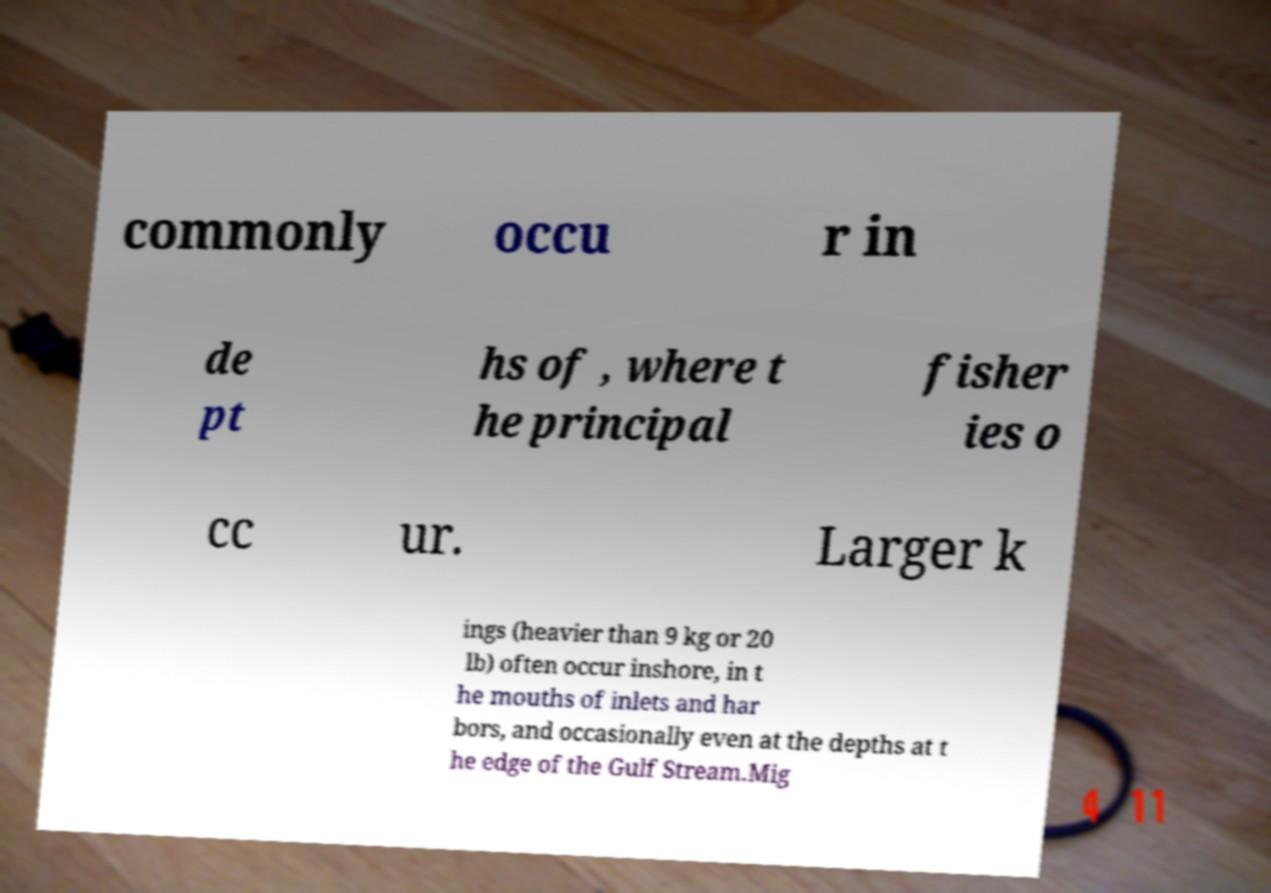Could you extract and type out the text from this image? commonly occu r in de pt hs of , where t he principal fisher ies o cc ur. Larger k ings (heavier than 9 kg or 20 lb) often occur inshore, in t he mouths of inlets and har bors, and occasionally even at the depths at t he edge of the Gulf Stream.Mig 